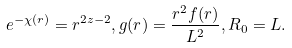Convert formula to latex. <formula><loc_0><loc_0><loc_500><loc_500>e ^ { - \chi ( r ) } = r ^ { 2 z - 2 } , g ( r ) = \frac { r ^ { 2 } f ( r ) } { L ^ { 2 } } , R _ { 0 } = L .</formula> 